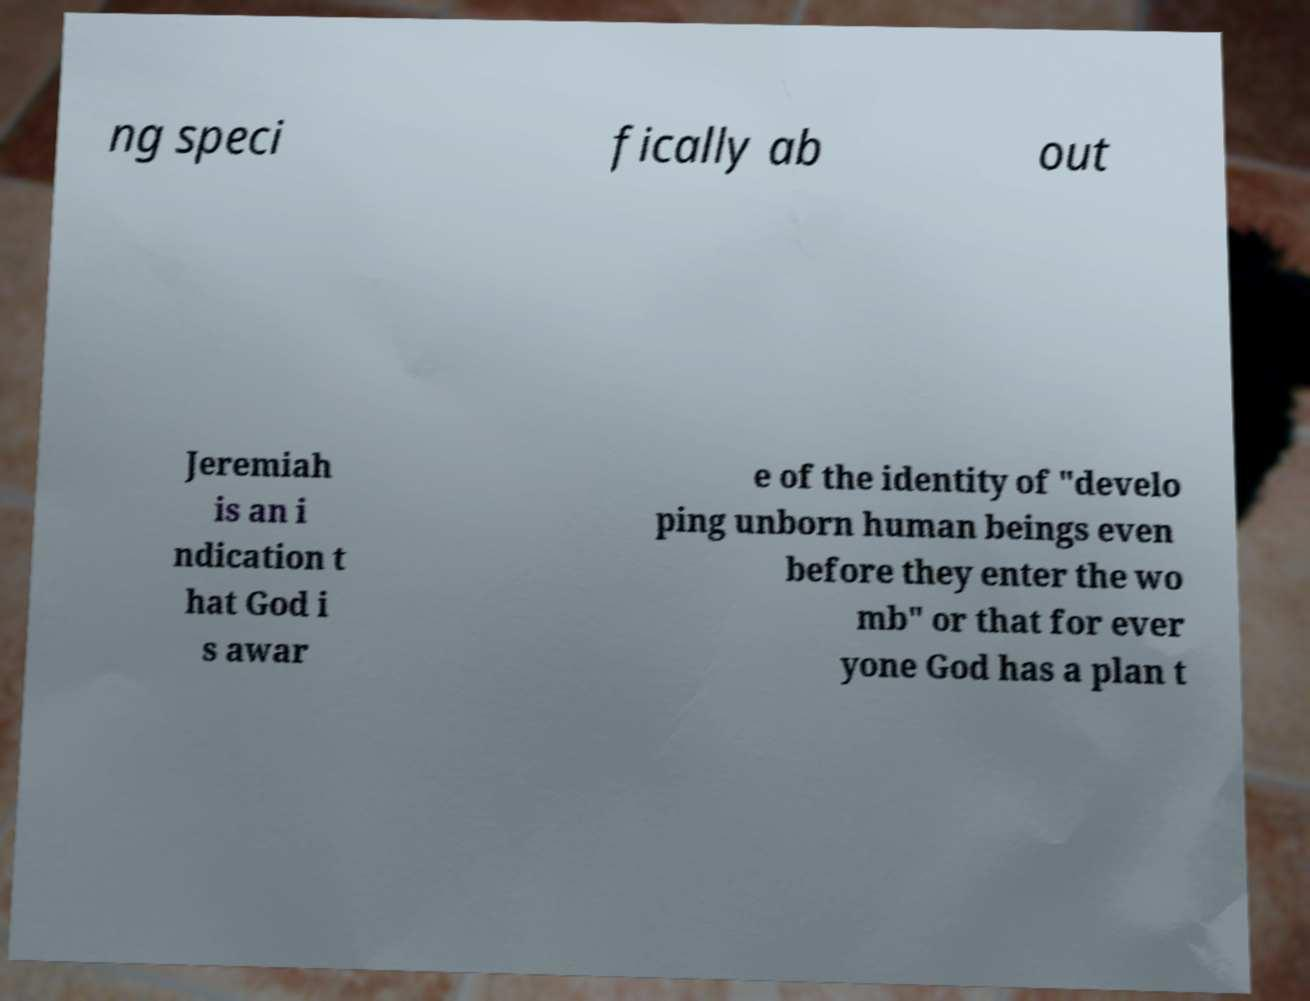What messages or text are displayed in this image? I need them in a readable, typed format. ng speci fically ab out Jeremiah is an i ndication t hat God i s awar e of the identity of "develo ping unborn human beings even before they enter the wo mb" or that for ever yone God has a plan t 